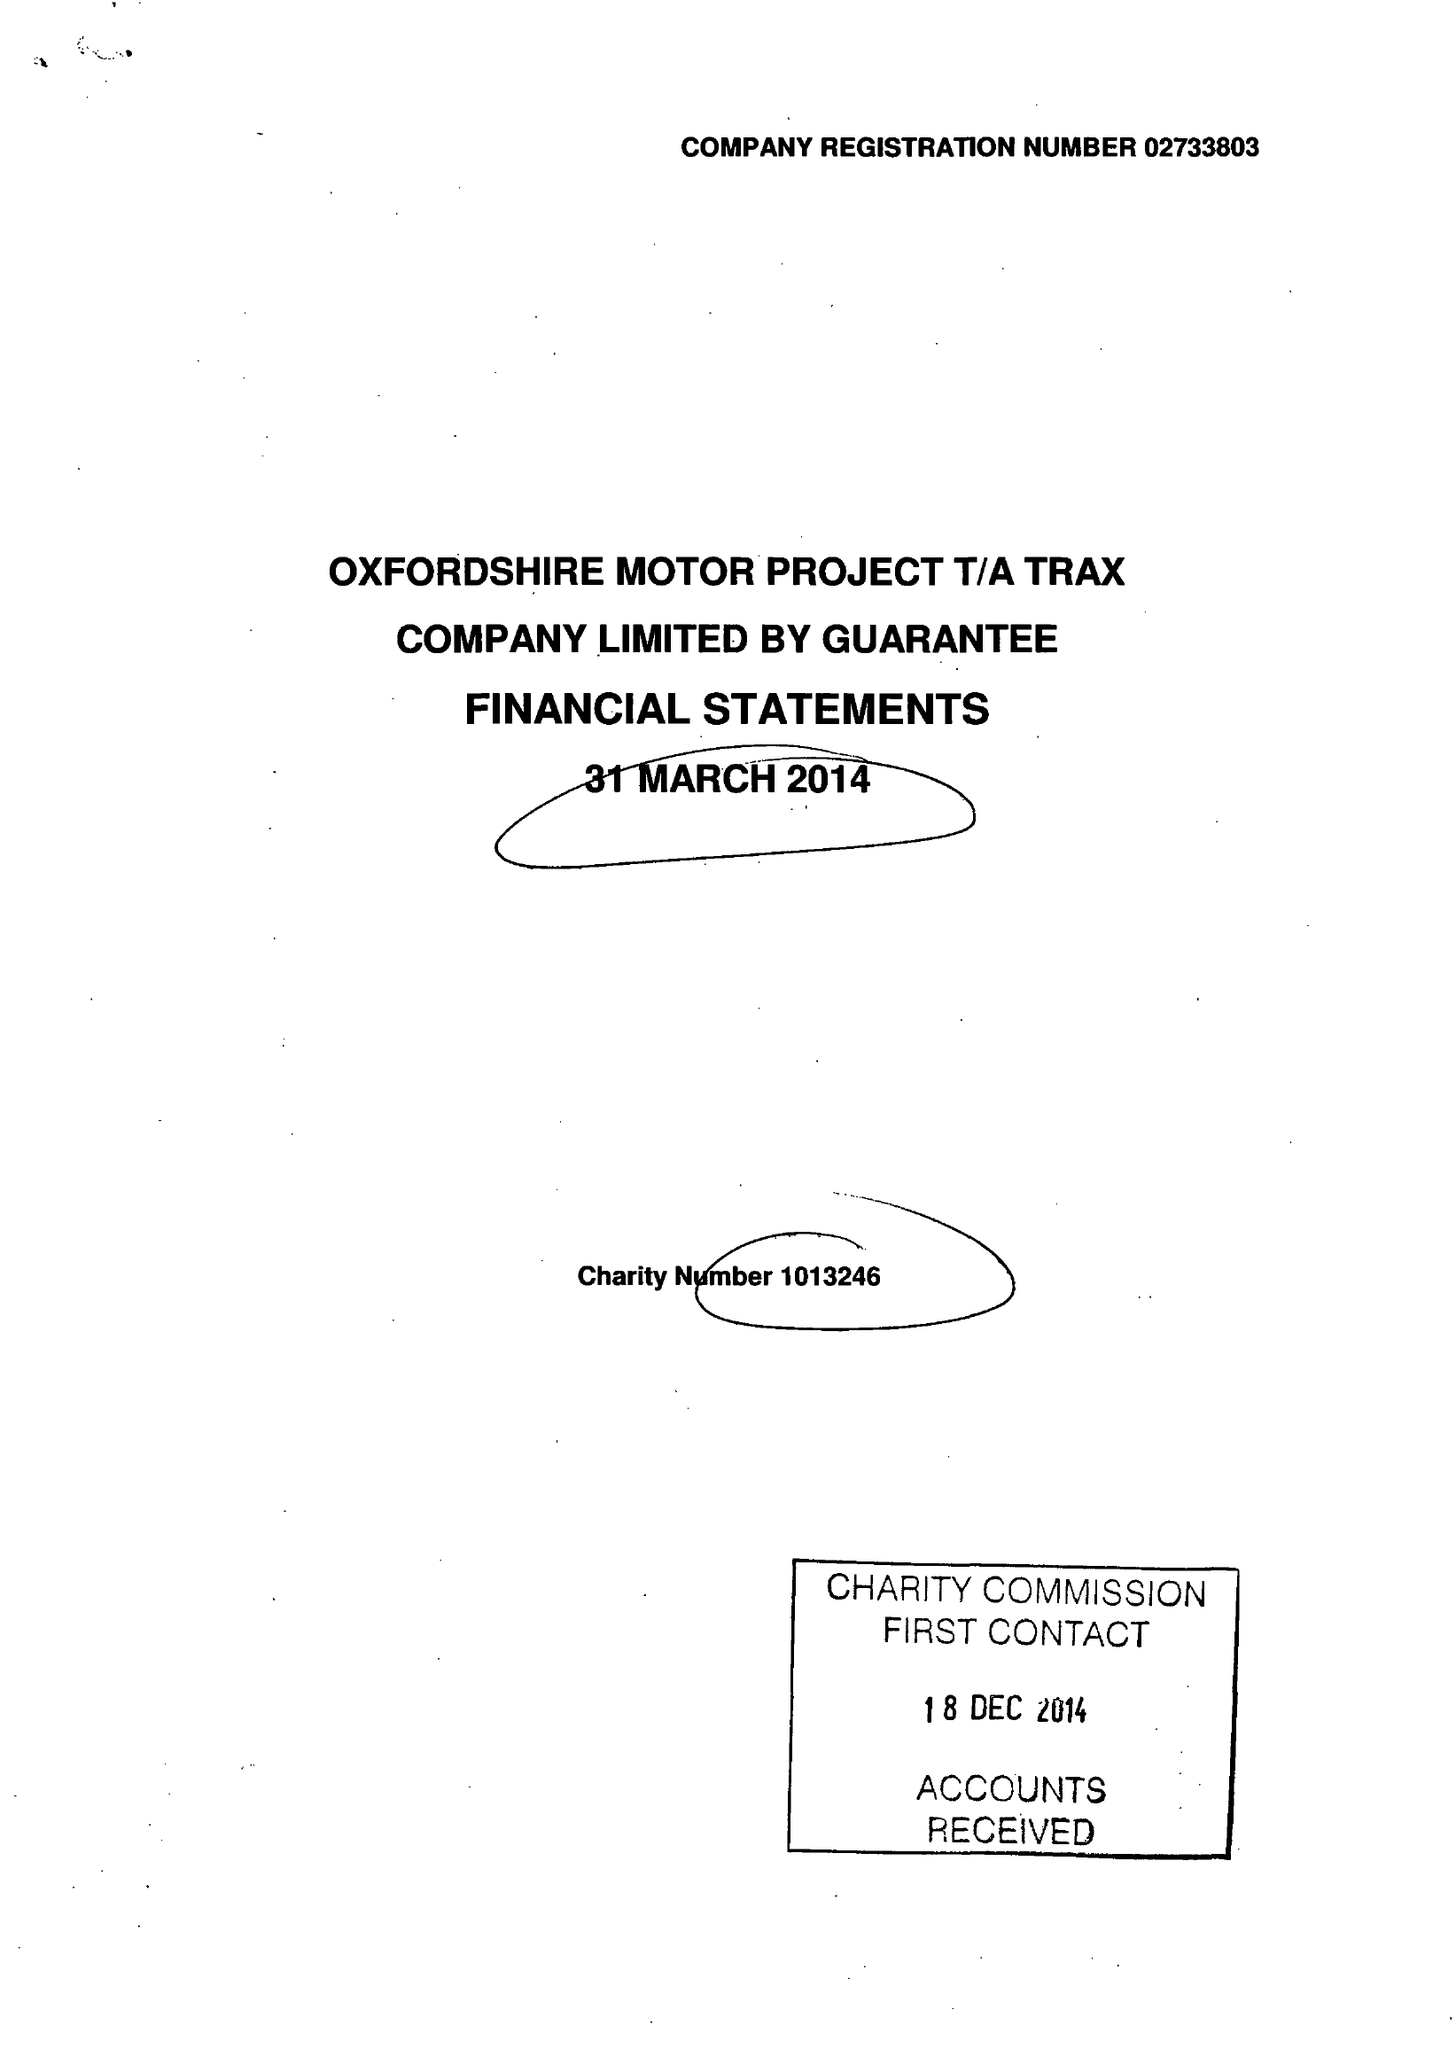What is the value for the charity_number?
Answer the question using a single word or phrase. 1013246 